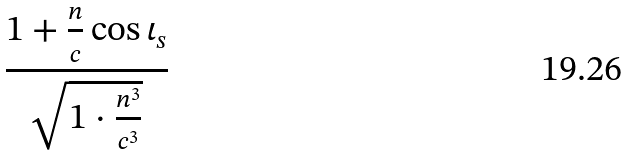Convert formula to latex. <formula><loc_0><loc_0><loc_500><loc_500>\frac { 1 + \frac { n } { c } \cos \iota _ { s } } { \sqrt { 1 \cdot \frac { n ^ { 3 } } { c ^ { 3 } } } }</formula> 